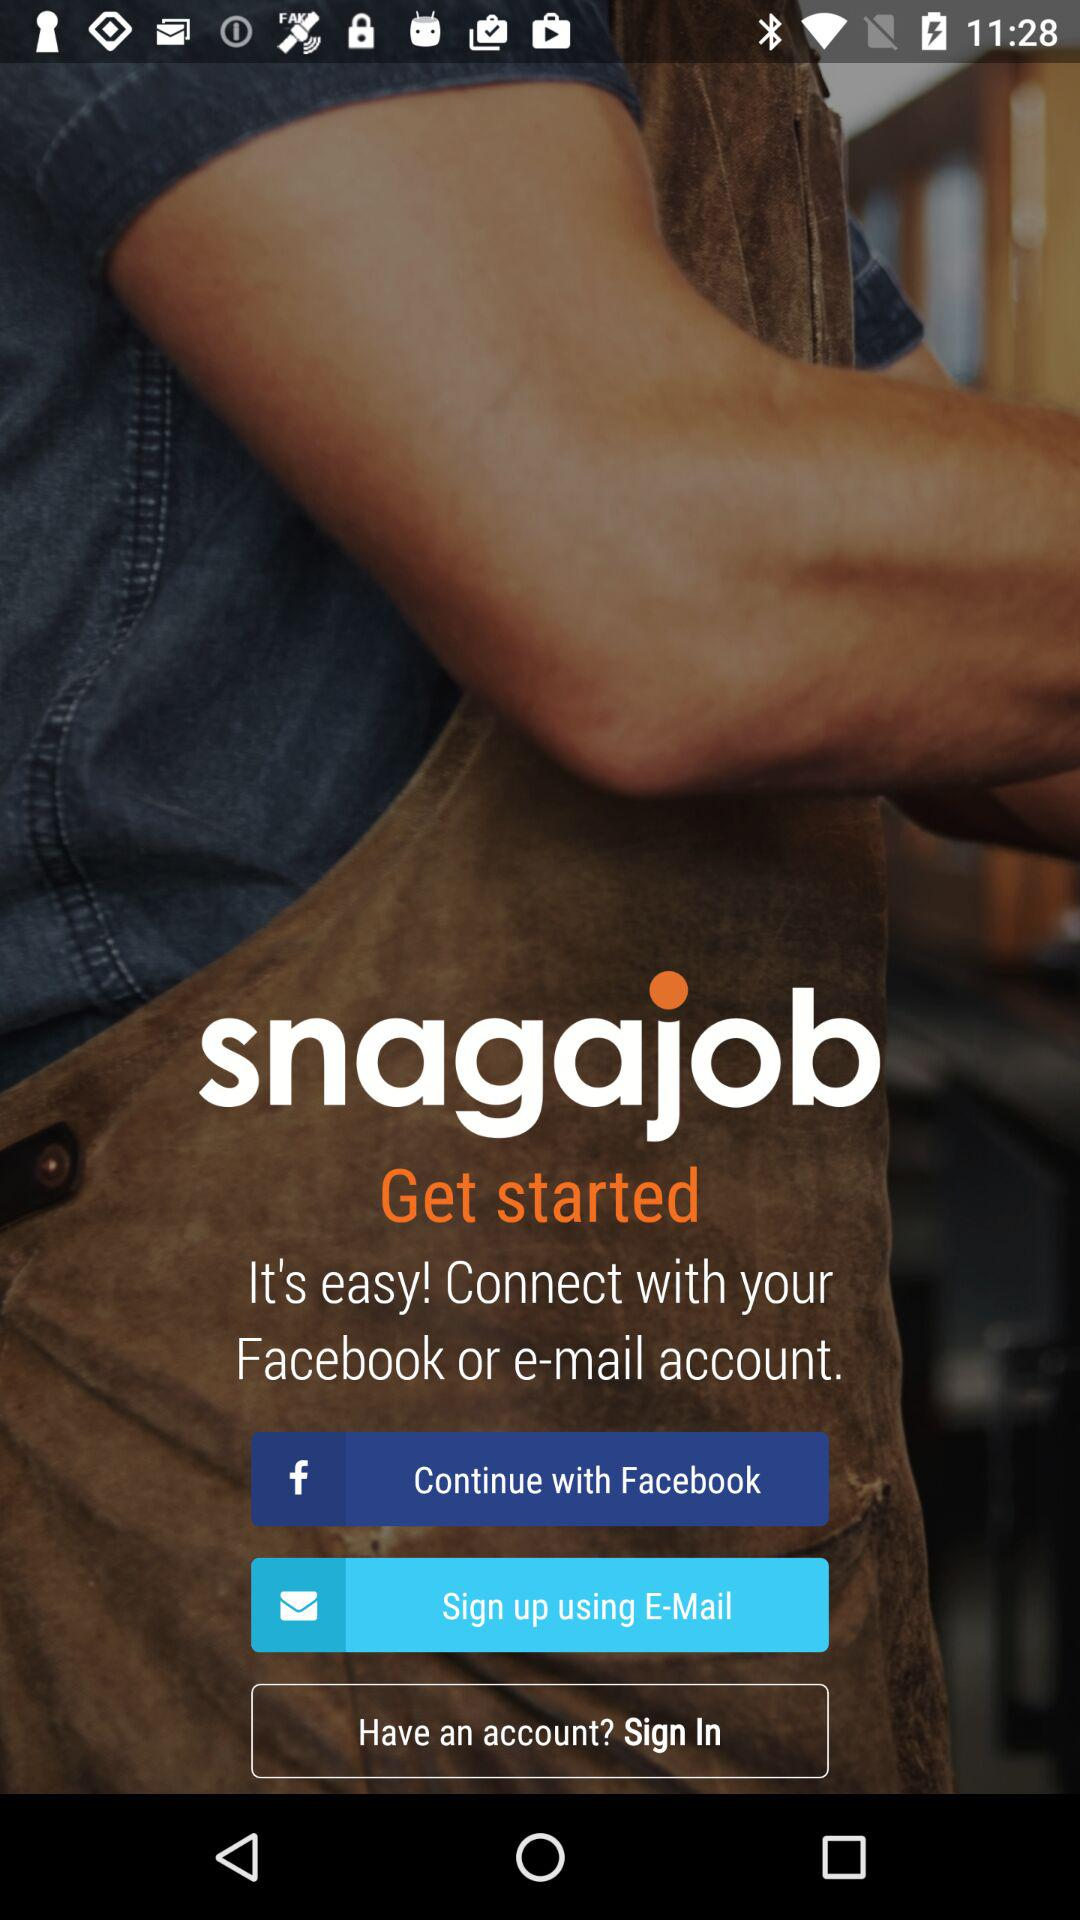What are the different options through which we can sign in? The different options through which you can sign in are "Facebook" and "E-Mail". 